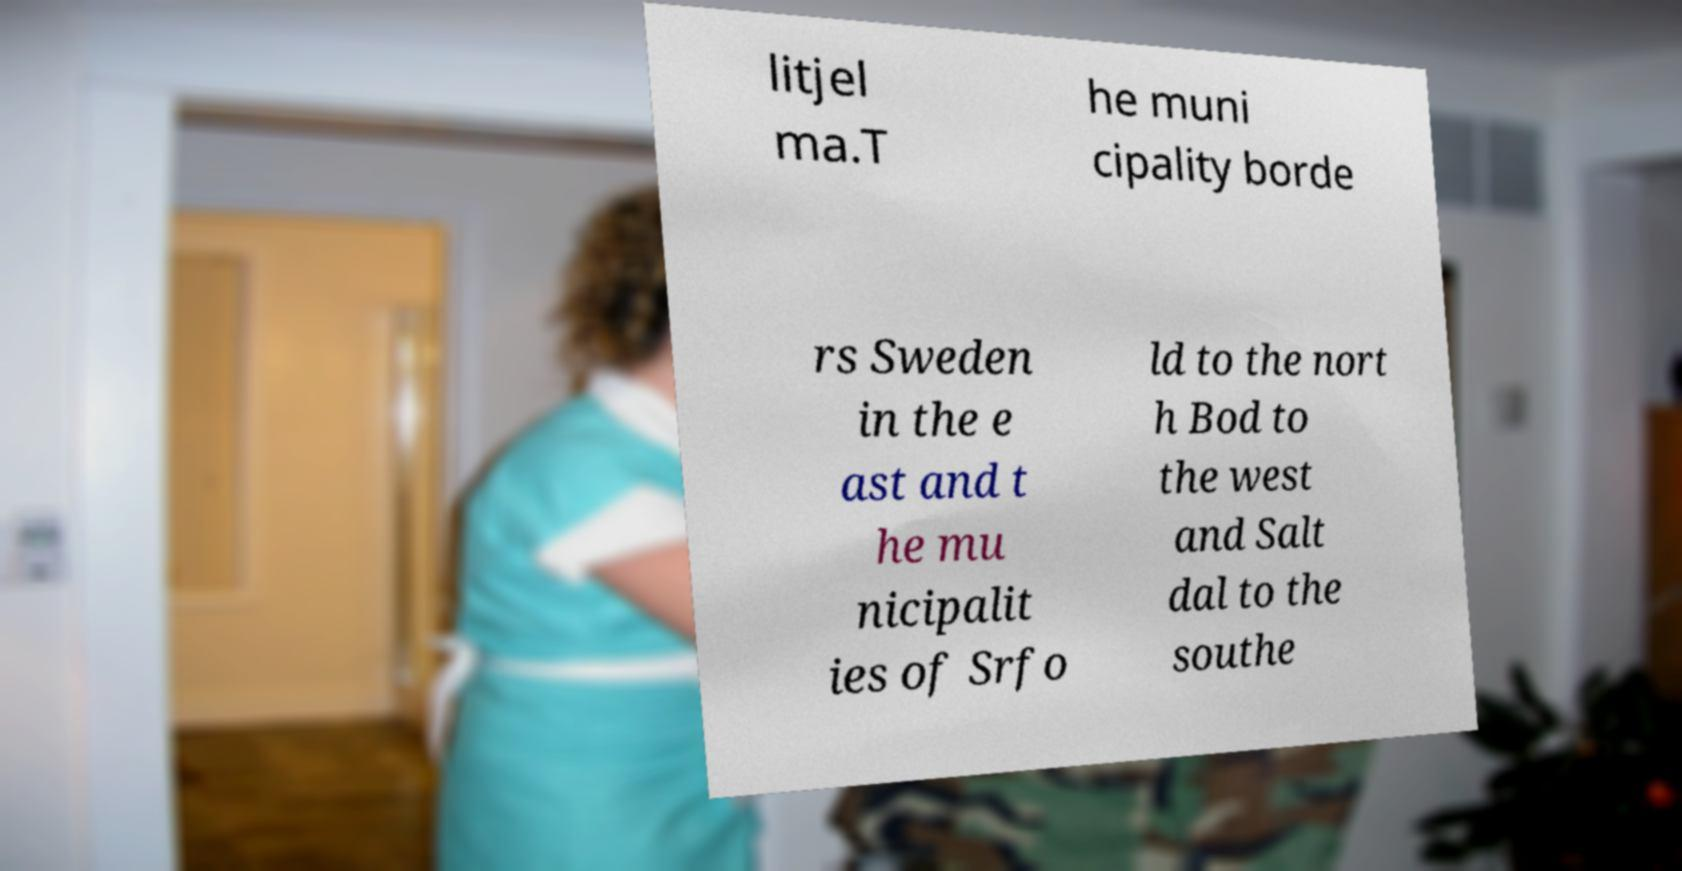Please read and relay the text visible in this image. What does it say? litjel ma.T he muni cipality borde rs Sweden in the e ast and t he mu nicipalit ies of Srfo ld to the nort h Bod to the west and Salt dal to the southe 